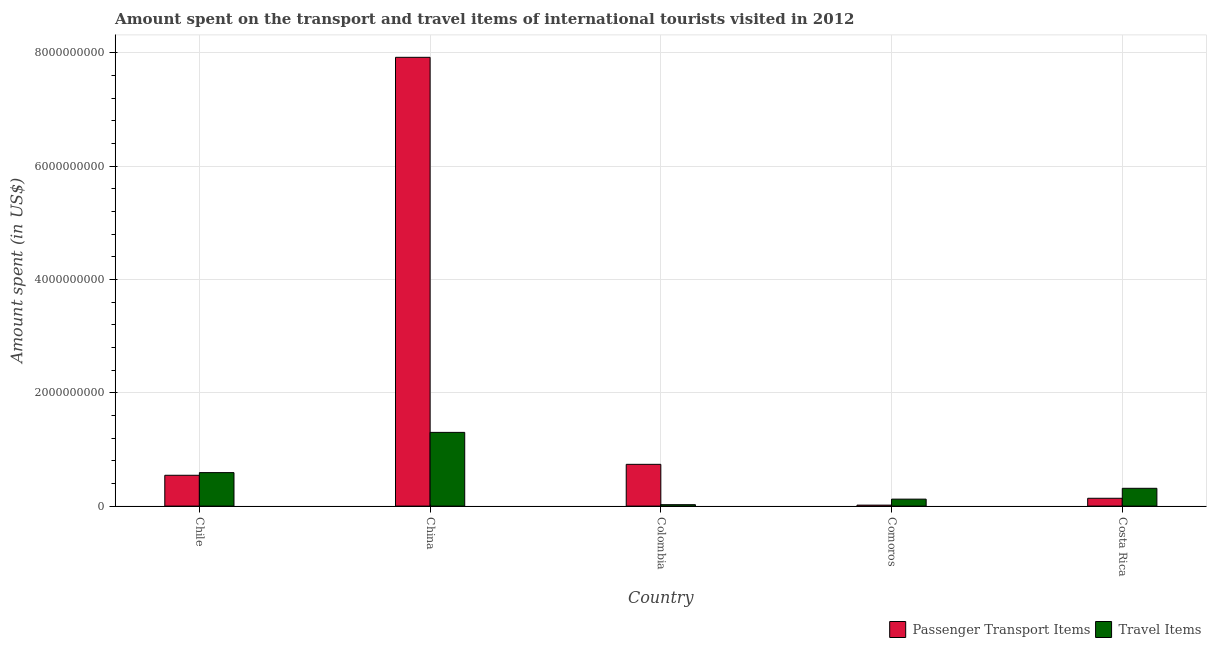How many groups of bars are there?
Ensure brevity in your answer.  5. Are the number of bars on each tick of the X-axis equal?
Ensure brevity in your answer.  Yes. What is the label of the 5th group of bars from the left?
Provide a short and direct response. Costa Rica. In how many cases, is the number of bars for a given country not equal to the number of legend labels?
Your answer should be very brief. 0. What is the amount spent in travel items in Costa Rica?
Your response must be concise. 3.14e+08. Across all countries, what is the maximum amount spent in travel items?
Make the answer very short. 1.30e+09. Across all countries, what is the minimum amount spent on passenger transport items?
Ensure brevity in your answer.  1.70e+07. In which country was the amount spent in travel items maximum?
Make the answer very short. China. In which country was the amount spent in travel items minimum?
Make the answer very short. Colombia. What is the total amount spent on passenger transport items in the graph?
Ensure brevity in your answer.  9.36e+09. What is the difference between the amount spent in travel items in China and that in Colombia?
Offer a very short reply. 1.28e+09. What is the difference between the amount spent on passenger transport items in China and the amount spent in travel items in Chile?
Offer a terse response. 7.33e+09. What is the average amount spent on passenger transport items per country?
Provide a short and direct response. 1.87e+09. What is the difference between the amount spent on passenger transport items and amount spent in travel items in Colombia?
Offer a very short reply. 7.12e+08. In how many countries, is the amount spent on passenger transport items greater than 400000000 US$?
Ensure brevity in your answer.  3. What is the ratio of the amount spent in travel items in Colombia to that in Costa Rica?
Give a very brief answer. 0.08. Is the amount spent on passenger transport items in Colombia less than that in Costa Rica?
Your answer should be compact. No. What is the difference between the highest and the second highest amount spent in travel items?
Make the answer very short. 7.10e+08. What is the difference between the highest and the lowest amount spent in travel items?
Your answer should be very brief. 1.28e+09. Is the sum of the amount spent on passenger transport items in Chile and Costa Rica greater than the maximum amount spent in travel items across all countries?
Provide a succinct answer. No. What does the 2nd bar from the left in Colombia represents?
Your response must be concise. Travel Items. What does the 1st bar from the right in Chile represents?
Your answer should be compact. Travel Items. Are all the bars in the graph horizontal?
Your response must be concise. No. How many countries are there in the graph?
Your response must be concise. 5. Does the graph contain any zero values?
Your answer should be very brief. No. Does the graph contain grids?
Give a very brief answer. Yes. How many legend labels are there?
Keep it short and to the point. 2. What is the title of the graph?
Provide a succinct answer. Amount spent on the transport and travel items of international tourists visited in 2012. What is the label or title of the X-axis?
Provide a short and direct response. Country. What is the label or title of the Y-axis?
Your response must be concise. Amount spent (in US$). What is the Amount spent (in US$) of Passenger Transport Items in Chile?
Your answer should be very brief. 5.44e+08. What is the Amount spent (in US$) of Travel Items in Chile?
Give a very brief answer. 5.91e+08. What is the Amount spent (in US$) of Passenger Transport Items in China?
Offer a very short reply. 7.92e+09. What is the Amount spent (in US$) of Travel Items in China?
Provide a short and direct response. 1.30e+09. What is the Amount spent (in US$) of Passenger Transport Items in Colombia?
Provide a short and direct response. 7.37e+08. What is the Amount spent (in US$) of Travel Items in Colombia?
Keep it short and to the point. 2.50e+07. What is the Amount spent (in US$) of Passenger Transport Items in Comoros?
Your answer should be very brief. 1.70e+07. What is the Amount spent (in US$) of Travel Items in Comoros?
Your response must be concise. 1.23e+08. What is the Amount spent (in US$) of Passenger Transport Items in Costa Rica?
Make the answer very short. 1.38e+08. What is the Amount spent (in US$) of Travel Items in Costa Rica?
Your answer should be compact. 3.14e+08. Across all countries, what is the maximum Amount spent (in US$) of Passenger Transport Items?
Give a very brief answer. 7.92e+09. Across all countries, what is the maximum Amount spent (in US$) of Travel Items?
Ensure brevity in your answer.  1.30e+09. Across all countries, what is the minimum Amount spent (in US$) in Passenger Transport Items?
Keep it short and to the point. 1.70e+07. Across all countries, what is the minimum Amount spent (in US$) in Travel Items?
Your answer should be very brief. 2.50e+07. What is the total Amount spent (in US$) of Passenger Transport Items in the graph?
Your answer should be compact. 9.36e+09. What is the total Amount spent (in US$) of Travel Items in the graph?
Make the answer very short. 2.35e+09. What is the difference between the Amount spent (in US$) of Passenger Transport Items in Chile and that in China?
Keep it short and to the point. -7.38e+09. What is the difference between the Amount spent (in US$) of Travel Items in Chile and that in China?
Offer a terse response. -7.10e+08. What is the difference between the Amount spent (in US$) in Passenger Transport Items in Chile and that in Colombia?
Provide a succinct answer. -1.93e+08. What is the difference between the Amount spent (in US$) in Travel Items in Chile and that in Colombia?
Make the answer very short. 5.66e+08. What is the difference between the Amount spent (in US$) of Passenger Transport Items in Chile and that in Comoros?
Keep it short and to the point. 5.27e+08. What is the difference between the Amount spent (in US$) of Travel Items in Chile and that in Comoros?
Offer a very short reply. 4.68e+08. What is the difference between the Amount spent (in US$) of Passenger Transport Items in Chile and that in Costa Rica?
Give a very brief answer. 4.06e+08. What is the difference between the Amount spent (in US$) in Travel Items in Chile and that in Costa Rica?
Give a very brief answer. 2.77e+08. What is the difference between the Amount spent (in US$) in Passenger Transport Items in China and that in Colombia?
Provide a short and direct response. 7.18e+09. What is the difference between the Amount spent (in US$) in Travel Items in China and that in Colombia?
Offer a terse response. 1.28e+09. What is the difference between the Amount spent (in US$) in Passenger Transport Items in China and that in Comoros?
Your answer should be compact. 7.90e+09. What is the difference between the Amount spent (in US$) in Travel Items in China and that in Comoros?
Your answer should be very brief. 1.18e+09. What is the difference between the Amount spent (in US$) of Passenger Transport Items in China and that in Costa Rica?
Your answer should be very brief. 7.78e+09. What is the difference between the Amount spent (in US$) of Travel Items in China and that in Costa Rica?
Keep it short and to the point. 9.87e+08. What is the difference between the Amount spent (in US$) in Passenger Transport Items in Colombia and that in Comoros?
Keep it short and to the point. 7.20e+08. What is the difference between the Amount spent (in US$) in Travel Items in Colombia and that in Comoros?
Your answer should be very brief. -9.80e+07. What is the difference between the Amount spent (in US$) of Passenger Transport Items in Colombia and that in Costa Rica?
Keep it short and to the point. 5.99e+08. What is the difference between the Amount spent (in US$) in Travel Items in Colombia and that in Costa Rica?
Give a very brief answer. -2.89e+08. What is the difference between the Amount spent (in US$) in Passenger Transport Items in Comoros and that in Costa Rica?
Your response must be concise. -1.21e+08. What is the difference between the Amount spent (in US$) in Travel Items in Comoros and that in Costa Rica?
Provide a succinct answer. -1.91e+08. What is the difference between the Amount spent (in US$) of Passenger Transport Items in Chile and the Amount spent (in US$) of Travel Items in China?
Offer a very short reply. -7.57e+08. What is the difference between the Amount spent (in US$) of Passenger Transport Items in Chile and the Amount spent (in US$) of Travel Items in Colombia?
Offer a very short reply. 5.19e+08. What is the difference between the Amount spent (in US$) in Passenger Transport Items in Chile and the Amount spent (in US$) in Travel Items in Comoros?
Give a very brief answer. 4.21e+08. What is the difference between the Amount spent (in US$) in Passenger Transport Items in Chile and the Amount spent (in US$) in Travel Items in Costa Rica?
Your answer should be very brief. 2.30e+08. What is the difference between the Amount spent (in US$) in Passenger Transport Items in China and the Amount spent (in US$) in Travel Items in Colombia?
Offer a terse response. 7.90e+09. What is the difference between the Amount spent (in US$) of Passenger Transport Items in China and the Amount spent (in US$) of Travel Items in Comoros?
Provide a short and direct response. 7.80e+09. What is the difference between the Amount spent (in US$) of Passenger Transport Items in China and the Amount spent (in US$) of Travel Items in Costa Rica?
Make the answer very short. 7.61e+09. What is the difference between the Amount spent (in US$) of Passenger Transport Items in Colombia and the Amount spent (in US$) of Travel Items in Comoros?
Provide a short and direct response. 6.14e+08. What is the difference between the Amount spent (in US$) in Passenger Transport Items in Colombia and the Amount spent (in US$) in Travel Items in Costa Rica?
Ensure brevity in your answer.  4.23e+08. What is the difference between the Amount spent (in US$) in Passenger Transport Items in Comoros and the Amount spent (in US$) in Travel Items in Costa Rica?
Your answer should be very brief. -2.97e+08. What is the average Amount spent (in US$) in Passenger Transport Items per country?
Ensure brevity in your answer.  1.87e+09. What is the average Amount spent (in US$) in Travel Items per country?
Provide a short and direct response. 4.71e+08. What is the difference between the Amount spent (in US$) in Passenger Transport Items and Amount spent (in US$) in Travel Items in Chile?
Provide a short and direct response. -4.70e+07. What is the difference between the Amount spent (in US$) in Passenger Transport Items and Amount spent (in US$) in Travel Items in China?
Offer a very short reply. 6.62e+09. What is the difference between the Amount spent (in US$) of Passenger Transport Items and Amount spent (in US$) of Travel Items in Colombia?
Keep it short and to the point. 7.12e+08. What is the difference between the Amount spent (in US$) in Passenger Transport Items and Amount spent (in US$) in Travel Items in Comoros?
Offer a very short reply. -1.06e+08. What is the difference between the Amount spent (in US$) of Passenger Transport Items and Amount spent (in US$) of Travel Items in Costa Rica?
Ensure brevity in your answer.  -1.76e+08. What is the ratio of the Amount spent (in US$) in Passenger Transport Items in Chile to that in China?
Your answer should be very brief. 0.07. What is the ratio of the Amount spent (in US$) in Travel Items in Chile to that in China?
Your answer should be compact. 0.45. What is the ratio of the Amount spent (in US$) of Passenger Transport Items in Chile to that in Colombia?
Your answer should be compact. 0.74. What is the ratio of the Amount spent (in US$) in Travel Items in Chile to that in Colombia?
Provide a short and direct response. 23.64. What is the ratio of the Amount spent (in US$) of Travel Items in Chile to that in Comoros?
Provide a succinct answer. 4.8. What is the ratio of the Amount spent (in US$) of Passenger Transport Items in Chile to that in Costa Rica?
Ensure brevity in your answer.  3.94. What is the ratio of the Amount spent (in US$) of Travel Items in Chile to that in Costa Rica?
Provide a succinct answer. 1.88. What is the ratio of the Amount spent (in US$) of Passenger Transport Items in China to that in Colombia?
Give a very brief answer. 10.75. What is the ratio of the Amount spent (in US$) in Travel Items in China to that in Colombia?
Ensure brevity in your answer.  52.04. What is the ratio of the Amount spent (in US$) in Passenger Transport Items in China to that in Comoros?
Your response must be concise. 465.94. What is the ratio of the Amount spent (in US$) in Travel Items in China to that in Comoros?
Your response must be concise. 10.58. What is the ratio of the Amount spent (in US$) of Passenger Transport Items in China to that in Costa Rica?
Your answer should be very brief. 57.4. What is the ratio of the Amount spent (in US$) of Travel Items in China to that in Costa Rica?
Ensure brevity in your answer.  4.14. What is the ratio of the Amount spent (in US$) in Passenger Transport Items in Colombia to that in Comoros?
Offer a very short reply. 43.35. What is the ratio of the Amount spent (in US$) in Travel Items in Colombia to that in Comoros?
Offer a terse response. 0.2. What is the ratio of the Amount spent (in US$) in Passenger Transport Items in Colombia to that in Costa Rica?
Keep it short and to the point. 5.34. What is the ratio of the Amount spent (in US$) in Travel Items in Colombia to that in Costa Rica?
Your answer should be compact. 0.08. What is the ratio of the Amount spent (in US$) of Passenger Transport Items in Comoros to that in Costa Rica?
Provide a short and direct response. 0.12. What is the ratio of the Amount spent (in US$) in Travel Items in Comoros to that in Costa Rica?
Your response must be concise. 0.39. What is the difference between the highest and the second highest Amount spent (in US$) in Passenger Transport Items?
Your response must be concise. 7.18e+09. What is the difference between the highest and the second highest Amount spent (in US$) in Travel Items?
Provide a short and direct response. 7.10e+08. What is the difference between the highest and the lowest Amount spent (in US$) in Passenger Transport Items?
Offer a terse response. 7.90e+09. What is the difference between the highest and the lowest Amount spent (in US$) of Travel Items?
Provide a short and direct response. 1.28e+09. 